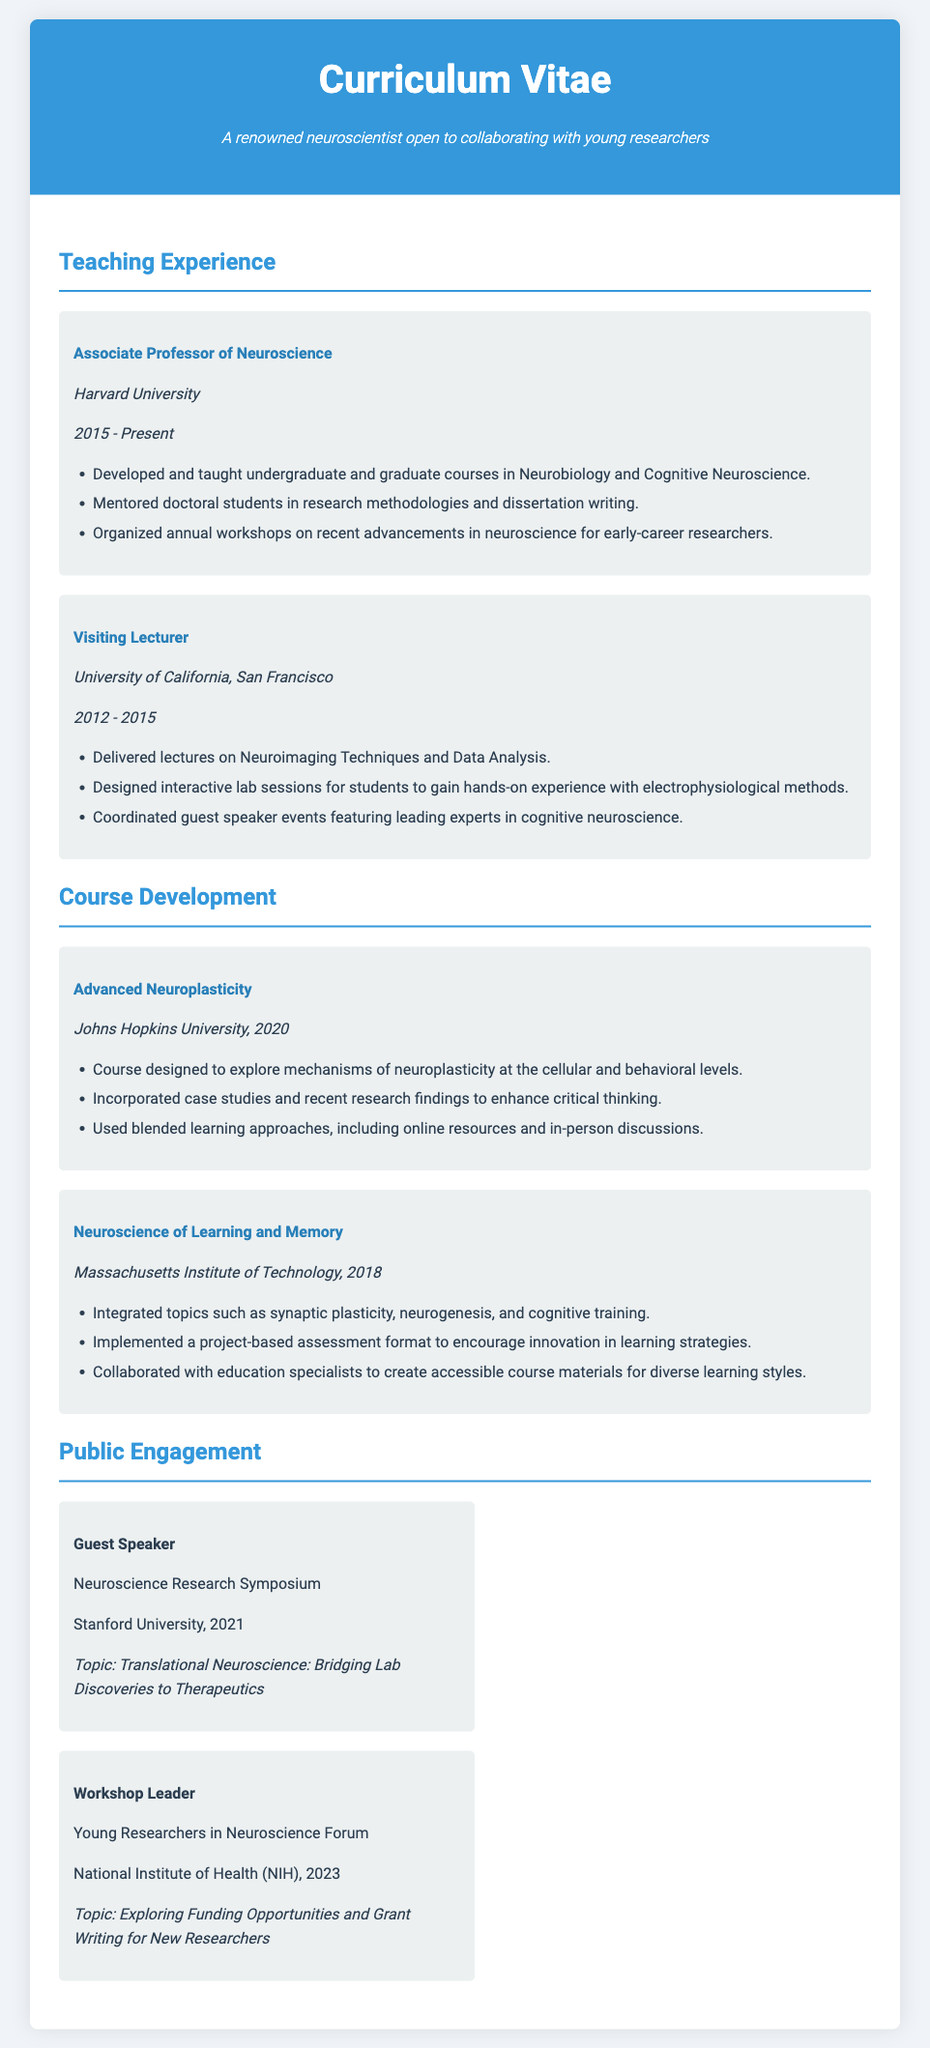What is the current position held by the neuroscientist? The current position is listed in the Teaching Experience section of the document, identifying their role as Associate Professor of Neuroscience.
Answer: Associate Professor of Neuroscience Which university is the neuroscientist affiliated with since 2015? The institution linked with the neuroscientist's current position, as per the provided document, is Harvard University.
Answer: Harvard University What course was developed in 2020? The document lists the courses developed under the Course Development section, specifically highlighting the course titled Advanced Neuroplasticity created in the year 2020.
Answer: Advanced Neuroplasticity How many years did the neuroscientist work at the University of California, San Francisco? A calculation of the duration from 2012 to 2015 gives a time span of three years, reflecting their engagement at that institution.
Answer: 3 years What role did the neuroscientist play at the Neuroscience Research Symposium? The document captures public engagement experiences of the neuroscientist, stating they participated as a guest speaker at the specified symposium.
Answer: Guest Speaker What unique approach was used in the course Neuroscience of Learning and Memory? The course incorporated a project-based assessment format, aimed at fostering innovation within learning strategies, as detailed in the Course Development section.
Answer: Project-based assessment Which workshop topic was presented at the NIH in 2023? The document specifies the workshop led at the NIH, which focused on funding opportunities and grant writing tailored for new researchers.
Answer: Exploring Funding Opportunities and Grant Writing for New Researchers Who was the target audience for the annual workshops organized by the neuroscientist? The audience described for the workshops focused on early-career researchers, providing professional development support as stated in the Teaching Experience section.
Answer: Early-career researchers What key educational element was incorporated in the Advanced Neuroplasticity course? The course included case studies and recent research findings, enhancing critical thinking among participants, as indicated in the course development summary.
Answer: Case studies and recent research findings 